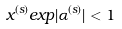<formula> <loc_0><loc_0><loc_500><loc_500>x ^ { ( s ) } e x p | \alpha ^ { ( s ) } | < 1</formula> 